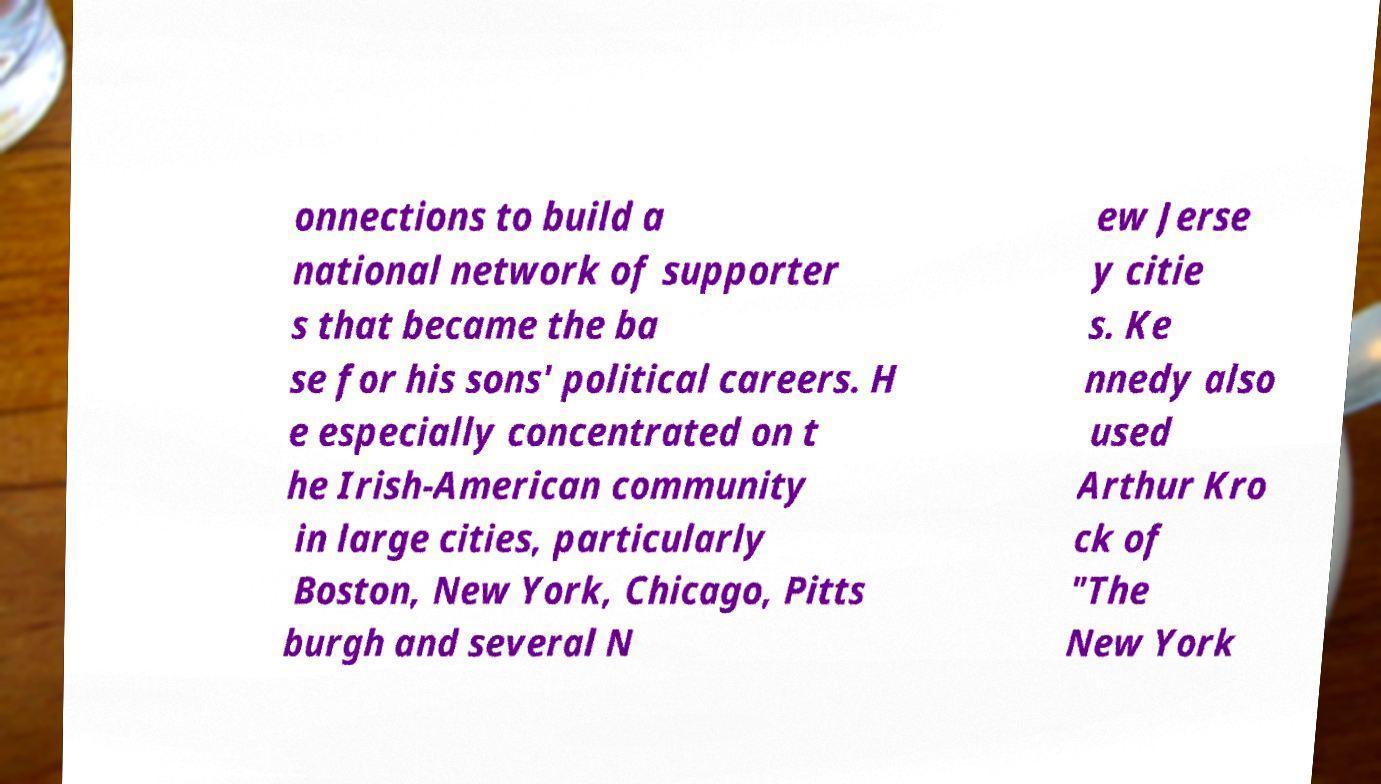Can you read and provide the text displayed in the image?This photo seems to have some interesting text. Can you extract and type it out for me? onnections to build a national network of supporter s that became the ba se for his sons' political careers. H e especially concentrated on t he Irish-American community in large cities, particularly Boston, New York, Chicago, Pitts burgh and several N ew Jerse y citie s. Ke nnedy also used Arthur Kro ck of "The New York 